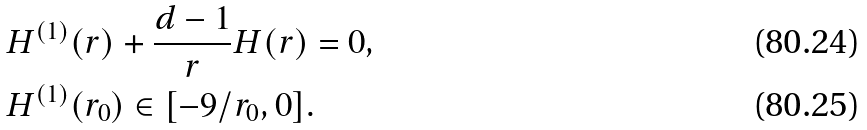Convert formula to latex. <formula><loc_0><loc_0><loc_500><loc_500>& H ^ { ( 1 ) } ( r ) + \frac { d - 1 } { r } H ( r ) = 0 , \\ & H ^ { ( 1 ) } ( r _ { 0 } ) \in [ - 9 / r _ { 0 } , 0 ] .</formula> 